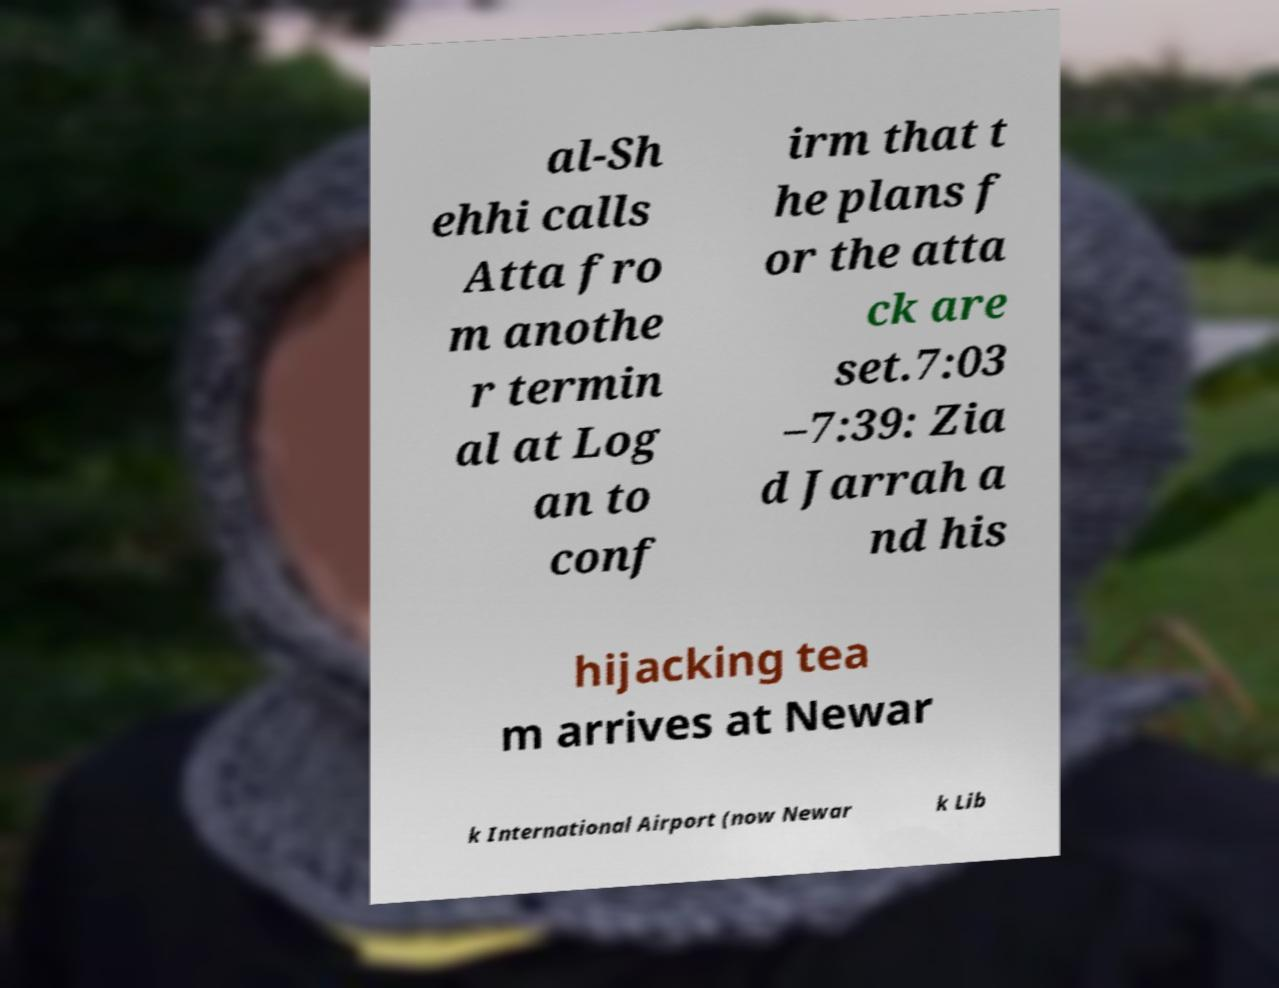What messages or text are displayed in this image? I need them in a readable, typed format. al-Sh ehhi calls Atta fro m anothe r termin al at Log an to conf irm that t he plans f or the atta ck are set.7:03 –7:39: Zia d Jarrah a nd his hijacking tea m arrives at Newar k International Airport (now Newar k Lib 